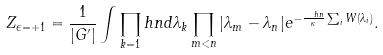Convert formula to latex. <formula><loc_0><loc_0><loc_500><loc_500>Z _ { \epsilon = + 1 } = \frac { 1 } { | G ^ { \prime } | } \int \prod _ { k = 1 } ^ { \ } h n d \lambda _ { k } \prod _ { m < n } | \lambda _ { m } - \lambda _ { n } | e ^ { - \frac { \ h n } { \kappa } \sum _ { i } W ( \lambda _ { i } ) } .</formula> 